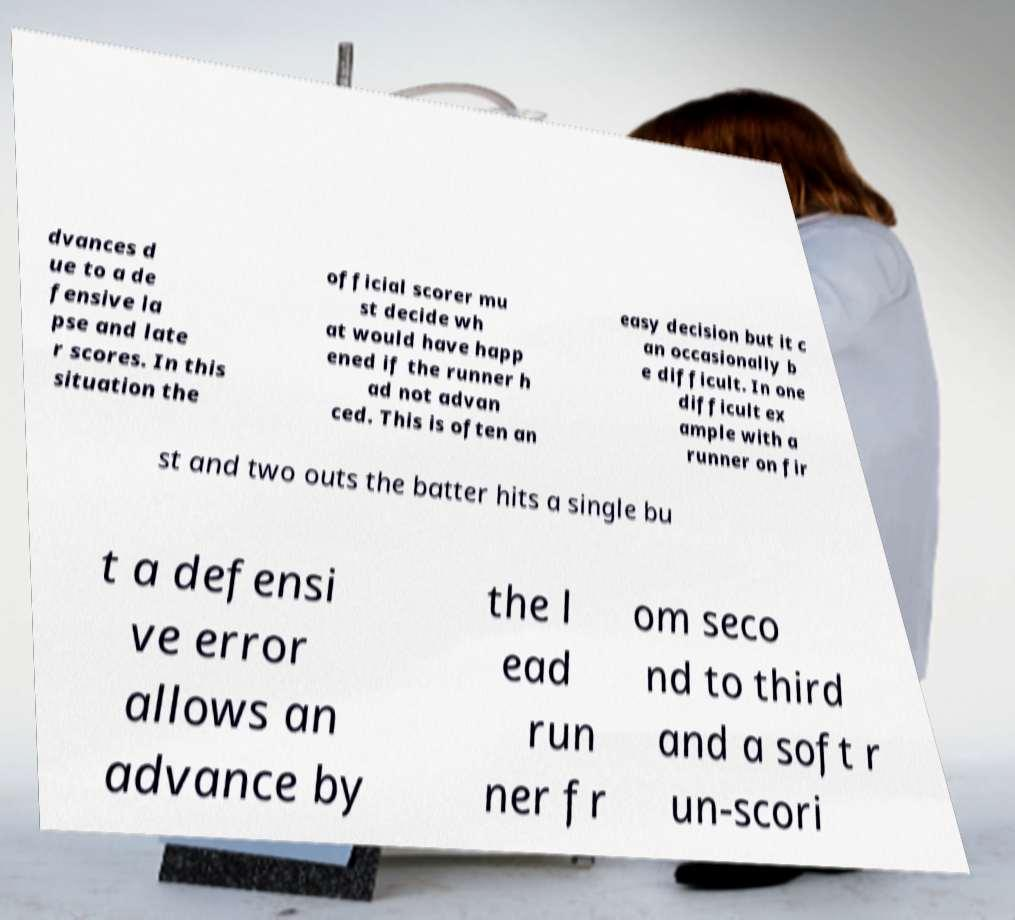Please read and relay the text visible in this image. What does it say? dvances d ue to a de fensive la pse and late r scores. In this situation the official scorer mu st decide wh at would have happ ened if the runner h ad not advan ced. This is often an easy decision but it c an occasionally b e difficult. In one difficult ex ample with a runner on fir st and two outs the batter hits a single bu t a defensi ve error allows an advance by the l ead run ner fr om seco nd to third and a soft r un-scori 